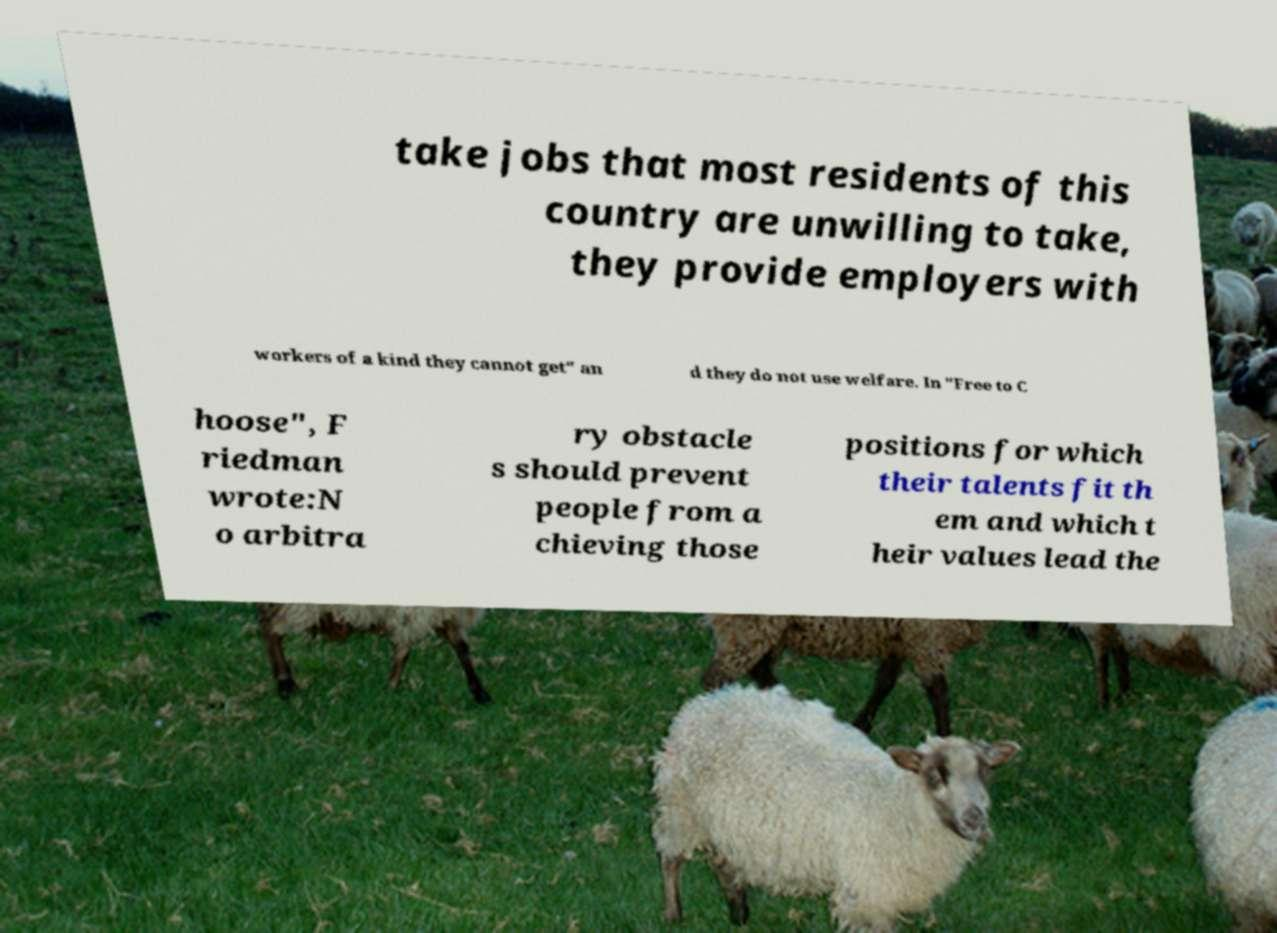There's text embedded in this image that I need extracted. Can you transcribe it verbatim? take jobs that most residents of this country are unwilling to take, they provide employers with workers of a kind they cannot get" an d they do not use welfare. In "Free to C hoose", F riedman wrote:N o arbitra ry obstacle s should prevent people from a chieving those positions for which their talents fit th em and which t heir values lead the 